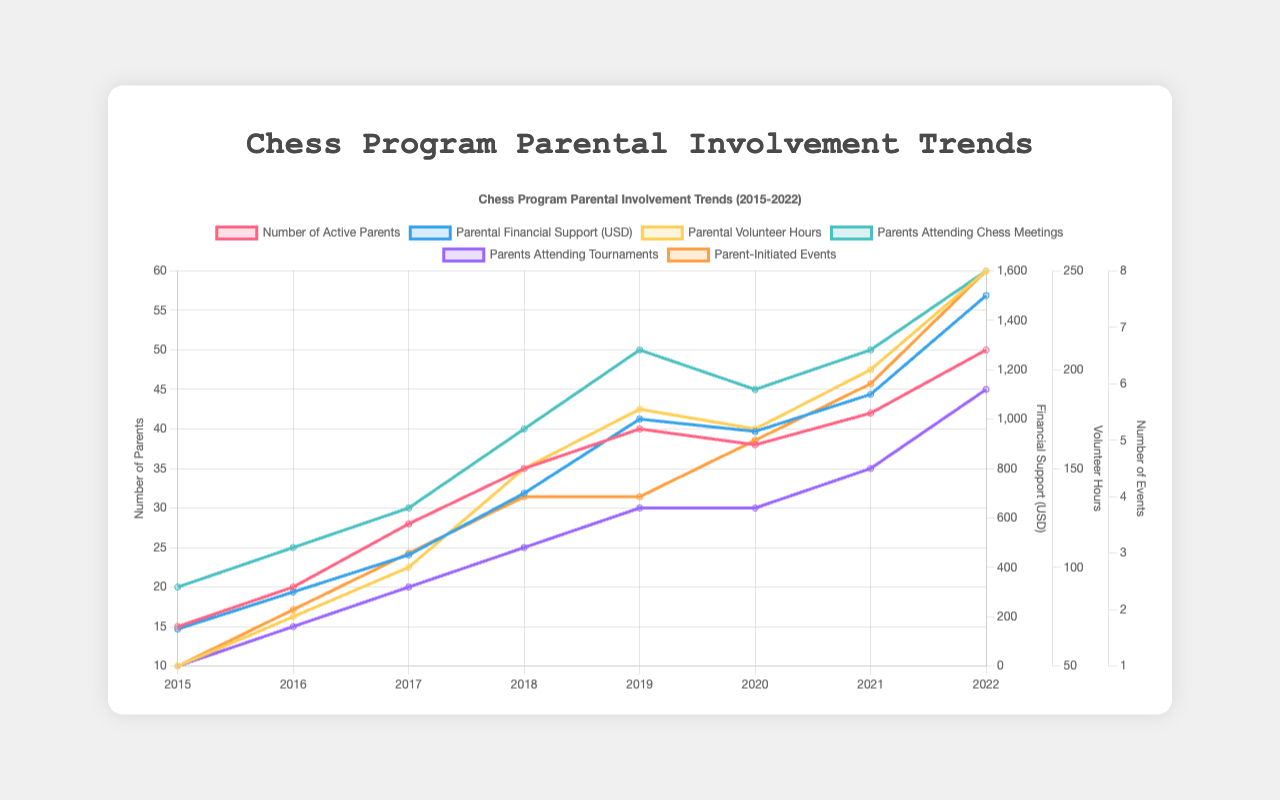What is the general trend in the number of active parents from 2015 to 2022? The figure shows a steady increase in the number of active parents, starting from 15 in 2015 and rising to 50 in 2022.
Answer: There is a steady increase How many more parents attended tournaments in 2022 compared to 2015? In 2015, 10 parents attended tournaments, while in 2022, 45 parents attended. The difference is 45 - 10 = 35.
Answer: 35 more parents Which year had the highest amount of parental financial support, and how much was it? Financial support is represented by a blue line. The highest point on this line is in 2022, where the parental financial support was $1500 USD.
Answer: 2022, $1500 USD By how much did parental volunteer hours increase from 2017 to 2022? In 2017, parental volunteer hours were 100 hours, and in 2022, it was 250 hours. The increase is 250 - 100 = 150 hours.
Answer: Increased by 150 hours What is the visual difference in the number of parent-initiated events between 2015 and 2022? There is a linear increase with the orange line showing that parent-initiated events rose from 1 event in 2015 to 8 events in 2022.
Answer: Increased visually from 1 to 8 Which metric shows a slight decrease between any two consecutive years, and what are those years? The metric "Parental Financial Support" shows a slight decrease between 2019 and 2020, from $1000 to $950.
Answer: Parental Financial Support, 2019-2020 In 2018, how many more parents were attending chess meetings compared to tournaments? In 2018, 40 parents attended chess meetings while 25 attended tournaments. The difference is 40 - 25 = 15.
Answer: 15 more parents What are the total parental volunteer hours recorded over the period from 2015 to 2022? Sum up the volunteer hours for each year: 50 + 75 + 100 + 150 + 180 + 170 + 200 + 250 = 1175 hours total.
Answer: 1175 hours List the years where the number of active parents remained the same or decreased compared to the previous year. The number of active parents decreased only between 2019 and 2020 (40 to 38). There are no years where the number stayed the same.
Answer: 2019-2020 